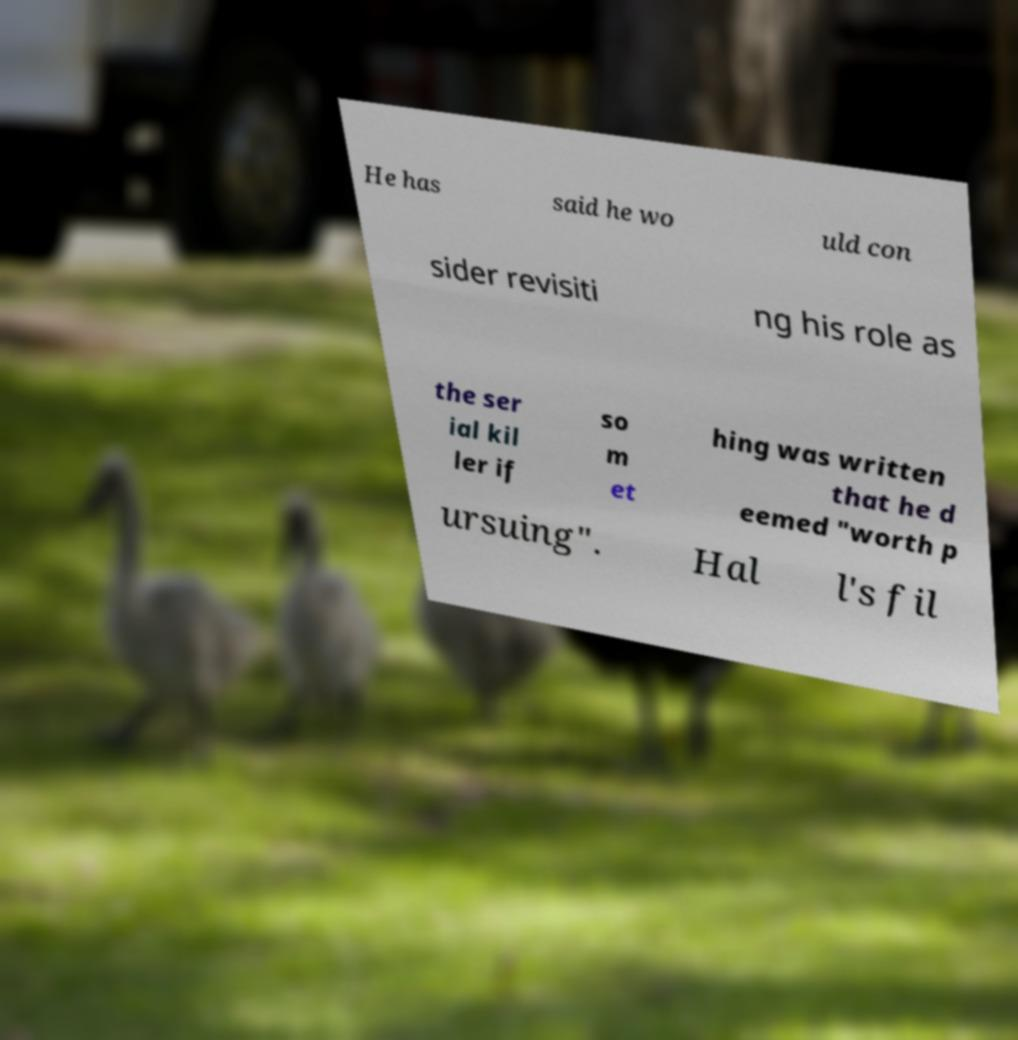There's text embedded in this image that I need extracted. Can you transcribe it verbatim? He has said he wo uld con sider revisiti ng his role as the ser ial kil ler if so m et hing was written that he d eemed "worth p ursuing". Hal l's fil 